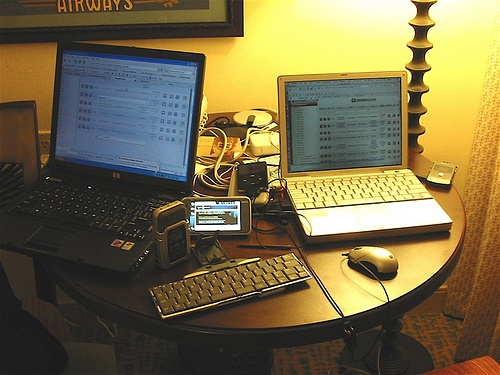Describe the objects in this image and their specific colors. I can see laptop in black and gray tones, laptop in black, gray, ivory, and khaki tones, chair in black and maroon tones, keyboard in black and gray tones, and keyboard in black, olive, and maroon tones in this image. 